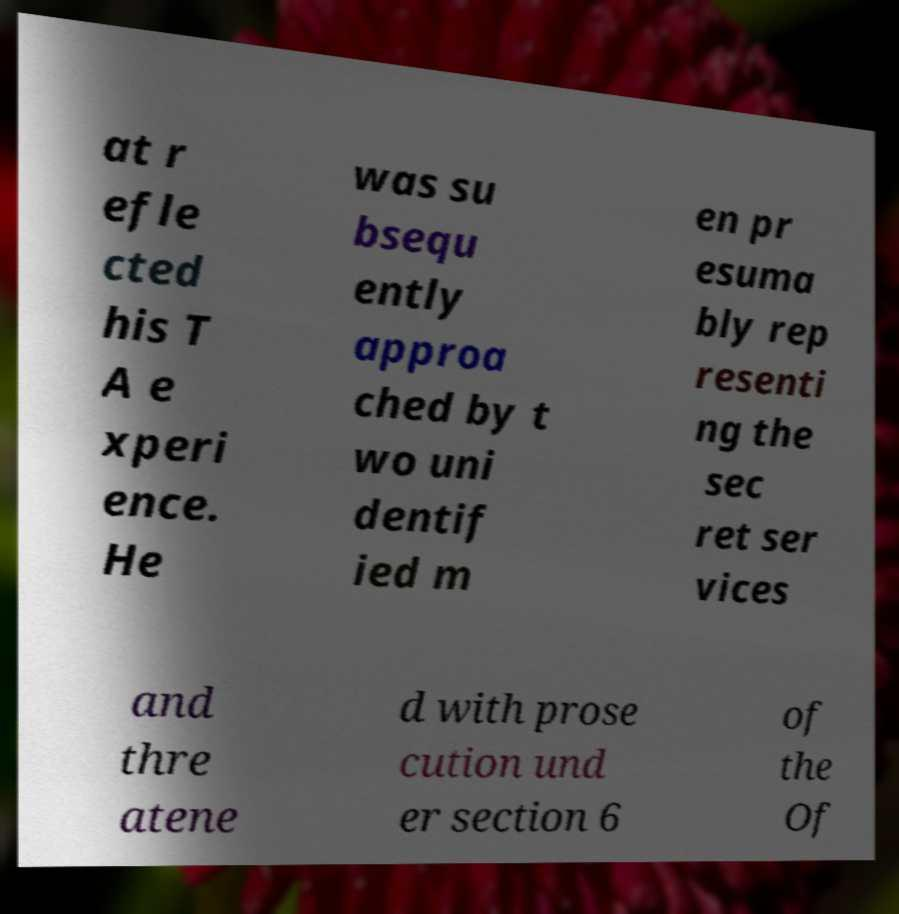What messages or text are displayed in this image? I need them in a readable, typed format. at r efle cted his T A e xperi ence. He was su bsequ ently approa ched by t wo uni dentif ied m en pr esuma bly rep resenti ng the sec ret ser vices and thre atene d with prose cution und er section 6 of the Of 